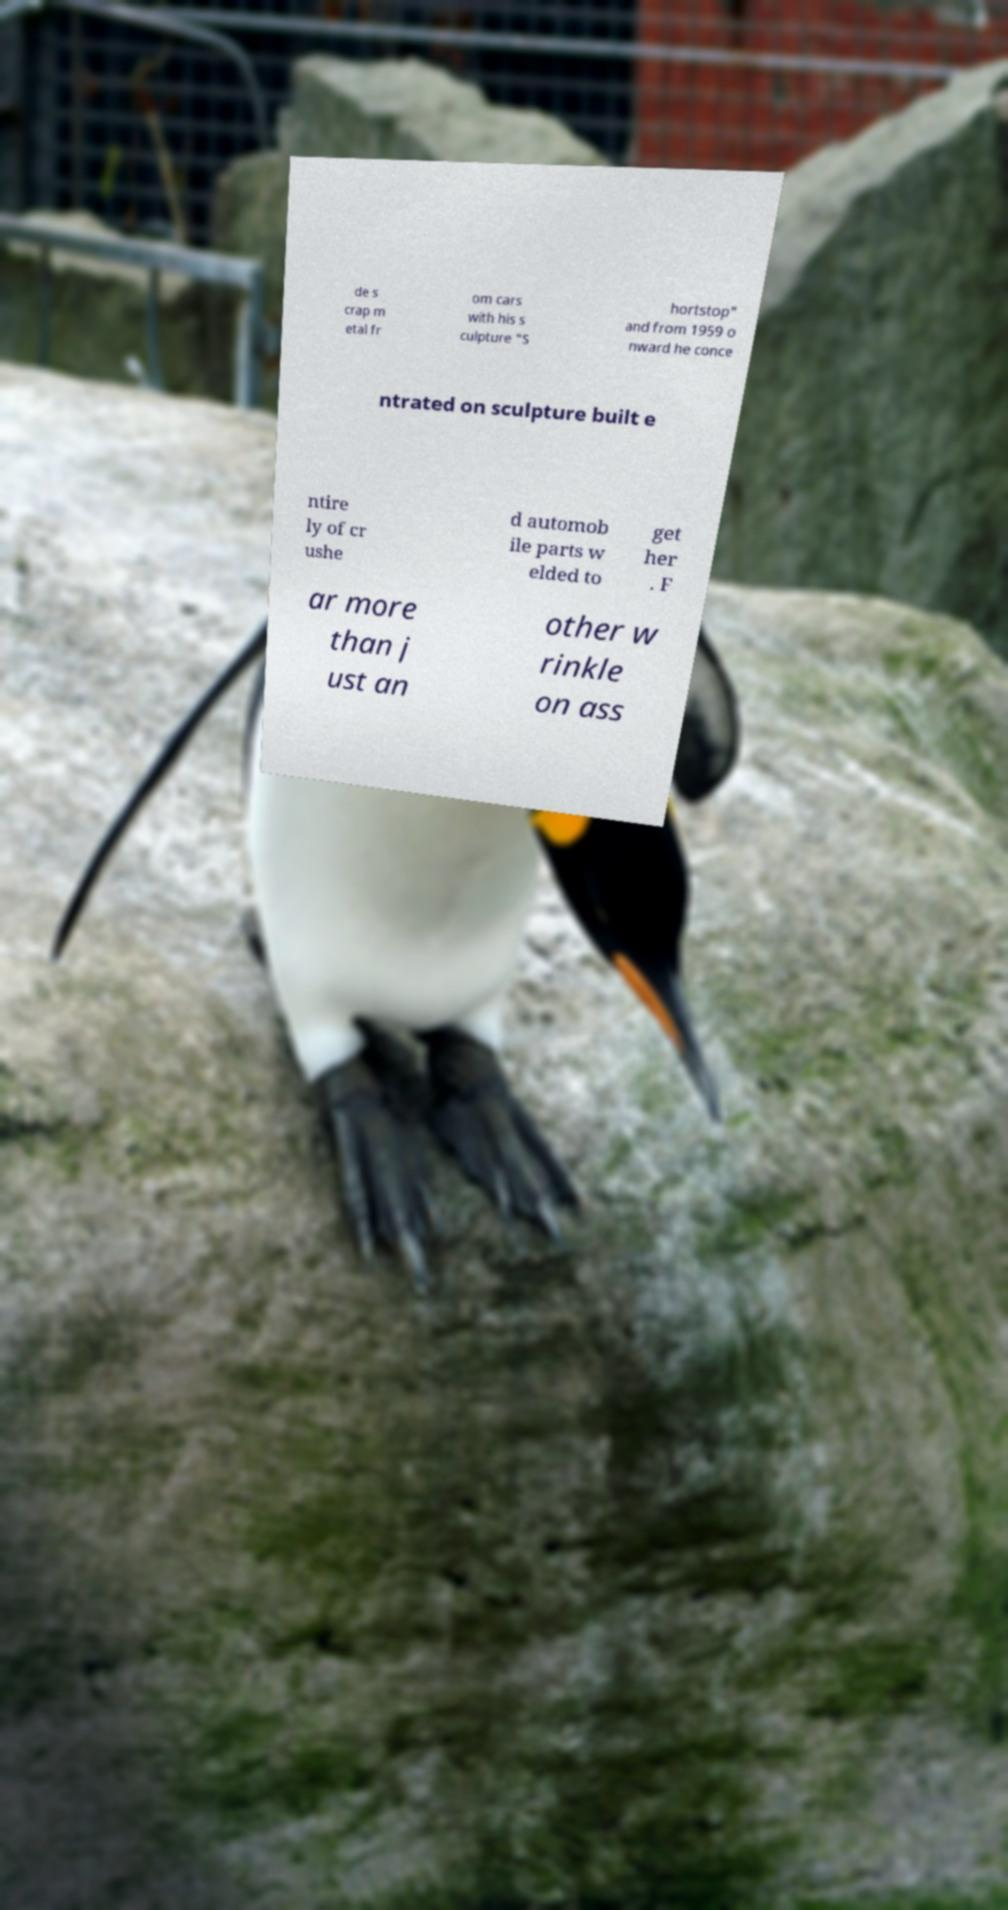Can you accurately transcribe the text from the provided image for me? de s crap m etal fr om cars with his s culpture "S hortstop" and from 1959 o nward he conce ntrated on sculpture built e ntire ly of cr ushe d automob ile parts w elded to get her . F ar more than j ust an other w rinkle on ass 